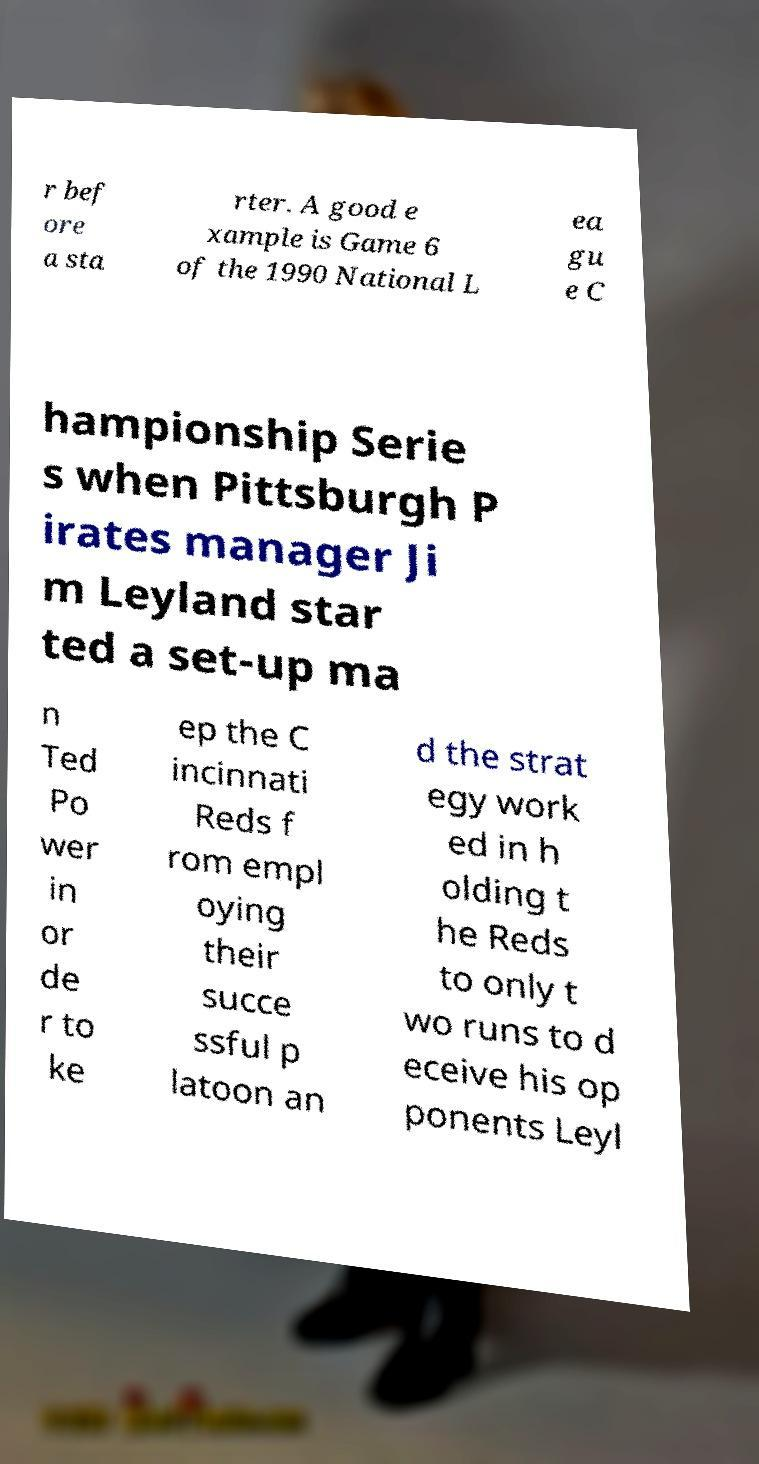Please identify and transcribe the text found in this image. r bef ore a sta rter. A good e xample is Game 6 of the 1990 National L ea gu e C hampionship Serie s when Pittsburgh P irates manager Ji m Leyland star ted a set-up ma n Ted Po wer in or de r to ke ep the C incinnati Reds f rom empl oying their succe ssful p latoon an d the strat egy work ed in h olding t he Reds to only t wo runs to d eceive his op ponents Leyl 